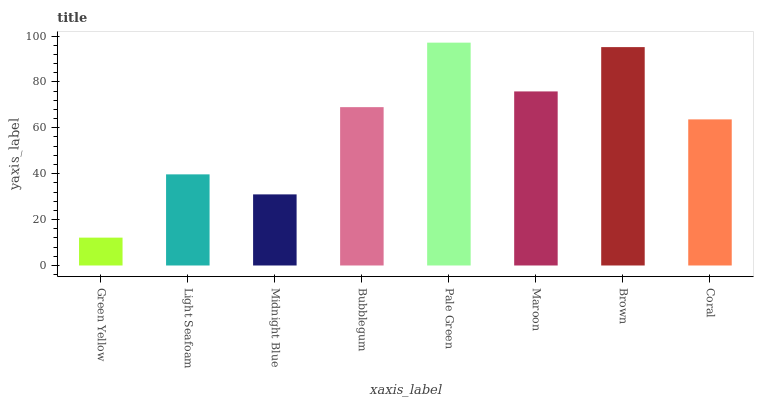Is Light Seafoam the minimum?
Answer yes or no. No. Is Light Seafoam the maximum?
Answer yes or no. No. Is Light Seafoam greater than Green Yellow?
Answer yes or no. Yes. Is Green Yellow less than Light Seafoam?
Answer yes or no. Yes. Is Green Yellow greater than Light Seafoam?
Answer yes or no. No. Is Light Seafoam less than Green Yellow?
Answer yes or no. No. Is Bubblegum the high median?
Answer yes or no. Yes. Is Coral the low median?
Answer yes or no. Yes. Is Midnight Blue the high median?
Answer yes or no. No. Is Midnight Blue the low median?
Answer yes or no. No. 